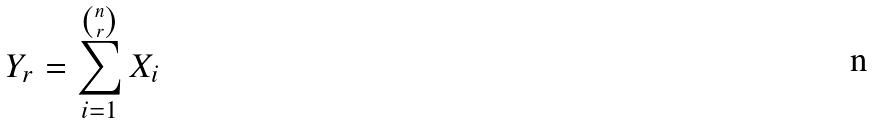Convert formula to latex. <formula><loc_0><loc_0><loc_500><loc_500>Y _ { r } = \sum _ { i = 1 } ^ { \binom { n } { r } } X _ { i }</formula> 